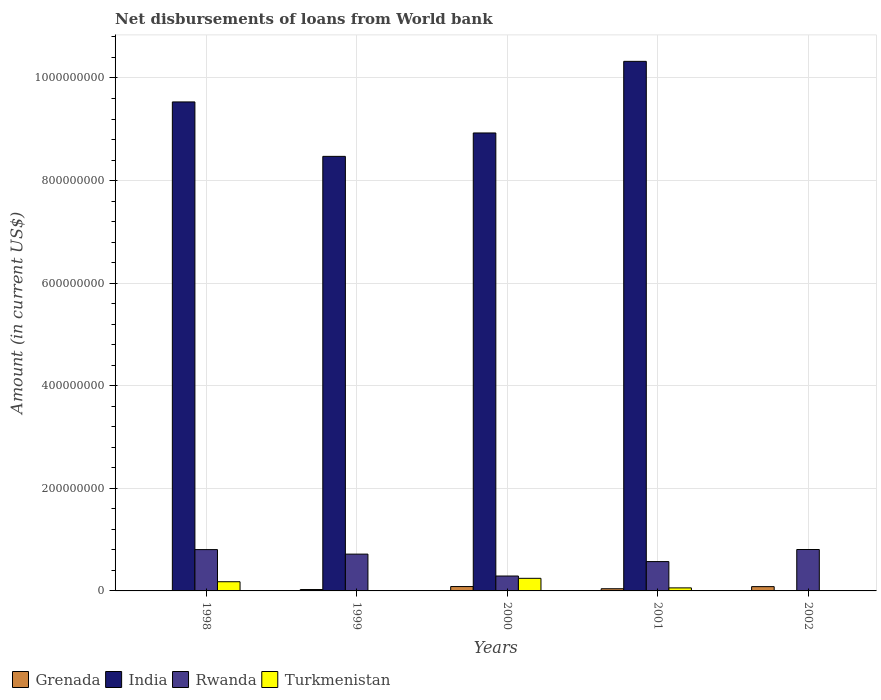How many different coloured bars are there?
Keep it short and to the point. 4. How many groups of bars are there?
Give a very brief answer. 5. Are the number of bars per tick equal to the number of legend labels?
Provide a short and direct response. No. Are the number of bars on each tick of the X-axis equal?
Ensure brevity in your answer.  No. How many bars are there on the 2nd tick from the left?
Your response must be concise. 4. How many bars are there on the 3rd tick from the right?
Your answer should be very brief. 4. In how many cases, is the number of bars for a given year not equal to the number of legend labels?
Offer a terse response. 2. What is the amount of loan disbursed from World Bank in Turkmenistan in 2002?
Provide a short and direct response. 0. Across all years, what is the maximum amount of loan disbursed from World Bank in Turkmenistan?
Make the answer very short. 2.46e+07. Across all years, what is the minimum amount of loan disbursed from World Bank in Rwanda?
Your answer should be very brief. 2.90e+07. In which year was the amount of loan disbursed from World Bank in Turkmenistan maximum?
Offer a terse response. 2000. What is the total amount of loan disbursed from World Bank in Grenada in the graph?
Make the answer very short. 2.38e+07. What is the difference between the amount of loan disbursed from World Bank in Turkmenistan in 1998 and that in 1999?
Offer a terse response. 1.73e+07. What is the difference between the amount of loan disbursed from World Bank in Grenada in 2000 and the amount of loan disbursed from World Bank in India in 2002?
Offer a terse response. 8.52e+06. What is the average amount of loan disbursed from World Bank in Grenada per year?
Offer a terse response. 4.77e+06. In the year 2001, what is the difference between the amount of loan disbursed from World Bank in Grenada and amount of loan disbursed from World Bank in India?
Provide a succinct answer. -1.03e+09. In how many years, is the amount of loan disbursed from World Bank in India greater than 920000000 US$?
Offer a very short reply. 2. What is the ratio of the amount of loan disbursed from World Bank in Rwanda in 2000 to that in 2002?
Give a very brief answer. 0.36. Is the difference between the amount of loan disbursed from World Bank in Grenada in 1999 and 2001 greater than the difference between the amount of loan disbursed from World Bank in India in 1999 and 2001?
Your answer should be very brief. Yes. What is the difference between the highest and the second highest amount of loan disbursed from World Bank in Rwanda?
Your answer should be compact. 1.67e+05. What is the difference between the highest and the lowest amount of loan disbursed from World Bank in Rwanda?
Your answer should be very brief. 5.17e+07. In how many years, is the amount of loan disbursed from World Bank in Rwanda greater than the average amount of loan disbursed from World Bank in Rwanda taken over all years?
Your response must be concise. 3. How many bars are there?
Keep it short and to the point. 17. Are the values on the major ticks of Y-axis written in scientific E-notation?
Your response must be concise. No. Does the graph contain any zero values?
Offer a terse response. Yes. Does the graph contain grids?
Give a very brief answer. Yes. How are the legend labels stacked?
Provide a succinct answer. Horizontal. What is the title of the graph?
Your answer should be compact. Net disbursements of loans from World bank. Does "Cameroon" appear as one of the legend labels in the graph?
Offer a terse response. No. What is the label or title of the Y-axis?
Keep it short and to the point. Amount (in current US$). What is the Amount (in current US$) in India in 1998?
Offer a terse response. 9.53e+08. What is the Amount (in current US$) of Rwanda in 1998?
Your response must be concise. 8.06e+07. What is the Amount (in current US$) of Turkmenistan in 1998?
Make the answer very short. 1.79e+07. What is the Amount (in current US$) in Grenada in 1999?
Provide a succinct answer. 2.70e+06. What is the Amount (in current US$) in India in 1999?
Make the answer very short. 8.47e+08. What is the Amount (in current US$) in Rwanda in 1999?
Offer a very short reply. 7.18e+07. What is the Amount (in current US$) in Turkmenistan in 1999?
Your response must be concise. 5.75e+05. What is the Amount (in current US$) in Grenada in 2000?
Offer a terse response. 8.52e+06. What is the Amount (in current US$) of India in 2000?
Make the answer very short. 8.93e+08. What is the Amount (in current US$) of Rwanda in 2000?
Ensure brevity in your answer.  2.90e+07. What is the Amount (in current US$) of Turkmenistan in 2000?
Give a very brief answer. 2.46e+07. What is the Amount (in current US$) in Grenada in 2001?
Offer a terse response. 4.25e+06. What is the Amount (in current US$) of India in 2001?
Provide a succinct answer. 1.03e+09. What is the Amount (in current US$) of Rwanda in 2001?
Provide a short and direct response. 5.72e+07. What is the Amount (in current US$) of Turkmenistan in 2001?
Offer a very short reply. 5.93e+06. What is the Amount (in current US$) of Grenada in 2002?
Make the answer very short. 8.38e+06. What is the Amount (in current US$) of India in 2002?
Offer a terse response. 0. What is the Amount (in current US$) of Rwanda in 2002?
Offer a terse response. 8.07e+07. What is the Amount (in current US$) in Turkmenistan in 2002?
Provide a short and direct response. 0. Across all years, what is the maximum Amount (in current US$) in Grenada?
Provide a succinct answer. 8.52e+06. Across all years, what is the maximum Amount (in current US$) of India?
Your answer should be compact. 1.03e+09. Across all years, what is the maximum Amount (in current US$) of Rwanda?
Provide a succinct answer. 8.07e+07. Across all years, what is the maximum Amount (in current US$) in Turkmenistan?
Offer a very short reply. 2.46e+07. Across all years, what is the minimum Amount (in current US$) in Grenada?
Give a very brief answer. 0. Across all years, what is the minimum Amount (in current US$) of Rwanda?
Your answer should be very brief. 2.90e+07. Across all years, what is the minimum Amount (in current US$) of Turkmenistan?
Give a very brief answer. 0. What is the total Amount (in current US$) in Grenada in the graph?
Provide a short and direct response. 2.38e+07. What is the total Amount (in current US$) in India in the graph?
Ensure brevity in your answer.  3.73e+09. What is the total Amount (in current US$) of Rwanda in the graph?
Your response must be concise. 3.19e+08. What is the total Amount (in current US$) in Turkmenistan in the graph?
Make the answer very short. 4.90e+07. What is the difference between the Amount (in current US$) of India in 1998 and that in 1999?
Make the answer very short. 1.06e+08. What is the difference between the Amount (in current US$) in Rwanda in 1998 and that in 1999?
Ensure brevity in your answer.  8.81e+06. What is the difference between the Amount (in current US$) of Turkmenistan in 1998 and that in 1999?
Your response must be concise. 1.73e+07. What is the difference between the Amount (in current US$) in India in 1998 and that in 2000?
Your answer should be very brief. 6.05e+07. What is the difference between the Amount (in current US$) in Rwanda in 1998 and that in 2000?
Ensure brevity in your answer.  5.15e+07. What is the difference between the Amount (in current US$) of Turkmenistan in 1998 and that in 2000?
Make the answer very short. -6.65e+06. What is the difference between the Amount (in current US$) of India in 1998 and that in 2001?
Provide a short and direct response. -7.91e+07. What is the difference between the Amount (in current US$) in Rwanda in 1998 and that in 2001?
Offer a very short reply. 2.34e+07. What is the difference between the Amount (in current US$) in Turkmenistan in 1998 and that in 2001?
Make the answer very short. 1.20e+07. What is the difference between the Amount (in current US$) in Rwanda in 1998 and that in 2002?
Provide a succinct answer. -1.67e+05. What is the difference between the Amount (in current US$) in Grenada in 1999 and that in 2000?
Provide a short and direct response. -5.82e+06. What is the difference between the Amount (in current US$) in India in 1999 and that in 2000?
Your response must be concise. -4.56e+07. What is the difference between the Amount (in current US$) in Rwanda in 1999 and that in 2000?
Your response must be concise. 4.27e+07. What is the difference between the Amount (in current US$) of Turkmenistan in 1999 and that in 2000?
Provide a short and direct response. -2.40e+07. What is the difference between the Amount (in current US$) of Grenada in 1999 and that in 2001?
Ensure brevity in your answer.  -1.55e+06. What is the difference between the Amount (in current US$) in India in 1999 and that in 2001?
Give a very brief answer. -1.85e+08. What is the difference between the Amount (in current US$) of Rwanda in 1999 and that in 2001?
Provide a succinct answer. 1.46e+07. What is the difference between the Amount (in current US$) of Turkmenistan in 1999 and that in 2001?
Give a very brief answer. -5.36e+06. What is the difference between the Amount (in current US$) in Grenada in 1999 and that in 2002?
Your answer should be very brief. -5.67e+06. What is the difference between the Amount (in current US$) in Rwanda in 1999 and that in 2002?
Keep it short and to the point. -8.98e+06. What is the difference between the Amount (in current US$) of Grenada in 2000 and that in 2001?
Your answer should be very brief. 4.27e+06. What is the difference between the Amount (in current US$) of India in 2000 and that in 2001?
Your answer should be compact. -1.40e+08. What is the difference between the Amount (in current US$) in Rwanda in 2000 and that in 2001?
Offer a terse response. -2.82e+07. What is the difference between the Amount (in current US$) in Turkmenistan in 2000 and that in 2001?
Give a very brief answer. 1.86e+07. What is the difference between the Amount (in current US$) in Grenada in 2000 and that in 2002?
Give a very brief answer. 1.44e+05. What is the difference between the Amount (in current US$) in Rwanda in 2000 and that in 2002?
Provide a short and direct response. -5.17e+07. What is the difference between the Amount (in current US$) of Grenada in 2001 and that in 2002?
Your response must be concise. -4.12e+06. What is the difference between the Amount (in current US$) in Rwanda in 2001 and that in 2002?
Keep it short and to the point. -2.35e+07. What is the difference between the Amount (in current US$) of India in 1998 and the Amount (in current US$) of Rwanda in 1999?
Provide a succinct answer. 8.82e+08. What is the difference between the Amount (in current US$) in India in 1998 and the Amount (in current US$) in Turkmenistan in 1999?
Keep it short and to the point. 9.53e+08. What is the difference between the Amount (in current US$) of Rwanda in 1998 and the Amount (in current US$) of Turkmenistan in 1999?
Your answer should be compact. 8.00e+07. What is the difference between the Amount (in current US$) of India in 1998 and the Amount (in current US$) of Rwanda in 2000?
Your response must be concise. 9.24e+08. What is the difference between the Amount (in current US$) of India in 1998 and the Amount (in current US$) of Turkmenistan in 2000?
Your answer should be very brief. 9.29e+08. What is the difference between the Amount (in current US$) in Rwanda in 1998 and the Amount (in current US$) in Turkmenistan in 2000?
Make the answer very short. 5.60e+07. What is the difference between the Amount (in current US$) of India in 1998 and the Amount (in current US$) of Rwanda in 2001?
Make the answer very short. 8.96e+08. What is the difference between the Amount (in current US$) in India in 1998 and the Amount (in current US$) in Turkmenistan in 2001?
Make the answer very short. 9.47e+08. What is the difference between the Amount (in current US$) in Rwanda in 1998 and the Amount (in current US$) in Turkmenistan in 2001?
Give a very brief answer. 7.46e+07. What is the difference between the Amount (in current US$) of India in 1998 and the Amount (in current US$) of Rwanda in 2002?
Keep it short and to the point. 8.73e+08. What is the difference between the Amount (in current US$) in Grenada in 1999 and the Amount (in current US$) in India in 2000?
Provide a short and direct response. -8.90e+08. What is the difference between the Amount (in current US$) in Grenada in 1999 and the Amount (in current US$) in Rwanda in 2000?
Offer a very short reply. -2.63e+07. What is the difference between the Amount (in current US$) of Grenada in 1999 and the Amount (in current US$) of Turkmenistan in 2000?
Keep it short and to the point. -2.19e+07. What is the difference between the Amount (in current US$) in India in 1999 and the Amount (in current US$) in Rwanda in 2000?
Your response must be concise. 8.18e+08. What is the difference between the Amount (in current US$) of India in 1999 and the Amount (in current US$) of Turkmenistan in 2000?
Provide a succinct answer. 8.23e+08. What is the difference between the Amount (in current US$) in Rwanda in 1999 and the Amount (in current US$) in Turkmenistan in 2000?
Keep it short and to the point. 4.72e+07. What is the difference between the Amount (in current US$) of Grenada in 1999 and the Amount (in current US$) of India in 2001?
Provide a succinct answer. -1.03e+09. What is the difference between the Amount (in current US$) of Grenada in 1999 and the Amount (in current US$) of Rwanda in 2001?
Offer a very short reply. -5.45e+07. What is the difference between the Amount (in current US$) in Grenada in 1999 and the Amount (in current US$) in Turkmenistan in 2001?
Your answer should be very brief. -3.23e+06. What is the difference between the Amount (in current US$) in India in 1999 and the Amount (in current US$) in Rwanda in 2001?
Offer a very short reply. 7.90e+08. What is the difference between the Amount (in current US$) of India in 1999 and the Amount (in current US$) of Turkmenistan in 2001?
Ensure brevity in your answer.  8.41e+08. What is the difference between the Amount (in current US$) of Rwanda in 1999 and the Amount (in current US$) of Turkmenistan in 2001?
Provide a succinct answer. 6.58e+07. What is the difference between the Amount (in current US$) of Grenada in 1999 and the Amount (in current US$) of Rwanda in 2002?
Your answer should be compact. -7.80e+07. What is the difference between the Amount (in current US$) of India in 1999 and the Amount (in current US$) of Rwanda in 2002?
Ensure brevity in your answer.  7.66e+08. What is the difference between the Amount (in current US$) in Grenada in 2000 and the Amount (in current US$) in India in 2001?
Your answer should be compact. -1.02e+09. What is the difference between the Amount (in current US$) in Grenada in 2000 and the Amount (in current US$) in Rwanda in 2001?
Ensure brevity in your answer.  -4.87e+07. What is the difference between the Amount (in current US$) of Grenada in 2000 and the Amount (in current US$) of Turkmenistan in 2001?
Give a very brief answer. 2.59e+06. What is the difference between the Amount (in current US$) of India in 2000 and the Amount (in current US$) of Rwanda in 2001?
Your answer should be compact. 8.36e+08. What is the difference between the Amount (in current US$) of India in 2000 and the Amount (in current US$) of Turkmenistan in 2001?
Your answer should be compact. 8.87e+08. What is the difference between the Amount (in current US$) of Rwanda in 2000 and the Amount (in current US$) of Turkmenistan in 2001?
Offer a terse response. 2.31e+07. What is the difference between the Amount (in current US$) of Grenada in 2000 and the Amount (in current US$) of Rwanda in 2002?
Keep it short and to the point. -7.22e+07. What is the difference between the Amount (in current US$) in India in 2000 and the Amount (in current US$) in Rwanda in 2002?
Your response must be concise. 8.12e+08. What is the difference between the Amount (in current US$) in Grenada in 2001 and the Amount (in current US$) in Rwanda in 2002?
Provide a short and direct response. -7.65e+07. What is the difference between the Amount (in current US$) of India in 2001 and the Amount (in current US$) of Rwanda in 2002?
Your answer should be compact. 9.52e+08. What is the average Amount (in current US$) in Grenada per year?
Keep it short and to the point. 4.77e+06. What is the average Amount (in current US$) of India per year?
Provide a short and direct response. 7.45e+08. What is the average Amount (in current US$) of Rwanda per year?
Your response must be concise. 6.39e+07. What is the average Amount (in current US$) in Turkmenistan per year?
Provide a succinct answer. 9.80e+06. In the year 1998, what is the difference between the Amount (in current US$) of India and Amount (in current US$) of Rwanda?
Your answer should be compact. 8.73e+08. In the year 1998, what is the difference between the Amount (in current US$) in India and Amount (in current US$) in Turkmenistan?
Offer a terse response. 9.35e+08. In the year 1998, what is the difference between the Amount (in current US$) of Rwanda and Amount (in current US$) of Turkmenistan?
Provide a succinct answer. 6.26e+07. In the year 1999, what is the difference between the Amount (in current US$) of Grenada and Amount (in current US$) of India?
Give a very brief answer. -8.44e+08. In the year 1999, what is the difference between the Amount (in current US$) in Grenada and Amount (in current US$) in Rwanda?
Your response must be concise. -6.91e+07. In the year 1999, what is the difference between the Amount (in current US$) of Grenada and Amount (in current US$) of Turkmenistan?
Your answer should be very brief. 2.13e+06. In the year 1999, what is the difference between the Amount (in current US$) of India and Amount (in current US$) of Rwanda?
Ensure brevity in your answer.  7.75e+08. In the year 1999, what is the difference between the Amount (in current US$) of India and Amount (in current US$) of Turkmenistan?
Give a very brief answer. 8.47e+08. In the year 1999, what is the difference between the Amount (in current US$) in Rwanda and Amount (in current US$) in Turkmenistan?
Your answer should be compact. 7.12e+07. In the year 2000, what is the difference between the Amount (in current US$) of Grenada and Amount (in current US$) of India?
Offer a very short reply. -8.84e+08. In the year 2000, what is the difference between the Amount (in current US$) in Grenada and Amount (in current US$) in Rwanda?
Your answer should be compact. -2.05e+07. In the year 2000, what is the difference between the Amount (in current US$) of Grenada and Amount (in current US$) of Turkmenistan?
Your answer should be very brief. -1.60e+07. In the year 2000, what is the difference between the Amount (in current US$) in India and Amount (in current US$) in Rwanda?
Keep it short and to the point. 8.64e+08. In the year 2000, what is the difference between the Amount (in current US$) in India and Amount (in current US$) in Turkmenistan?
Provide a short and direct response. 8.68e+08. In the year 2000, what is the difference between the Amount (in current US$) of Rwanda and Amount (in current US$) of Turkmenistan?
Offer a terse response. 4.47e+06. In the year 2001, what is the difference between the Amount (in current US$) of Grenada and Amount (in current US$) of India?
Provide a short and direct response. -1.03e+09. In the year 2001, what is the difference between the Amount (in current US$) in Grenada and Amount (in current US$) in Rwanda?
Ensure brevity in your answer.  -5.29e+07. In the year 2001, what is the difference between the Amount (in current US$) in Grenada and Amount (in current US$) in Turkmenistan?
Your answer should be compact. -1.68e+06. In the year 2001, what is the difference between the Amount (in current US$) in India and Amount (in current US$) in Rwanda?
Provide a succinct answer. 9.75e+08. In the year 2001, what is the difference between the Amount (in current US$) in India and Amount (in current US$) in Turkmenistan?
Your response must be concise. 1.03e+09. In the year 2001, what is the difference between the Amount (in current US$) in Rwanda and Amount (in current US$) in Turkmenistan?
Provide a succinct answer. 5.13e+07. In the year 2002, what is the difference between the Amount (in current US$) of Grenada and Amount (in current US$) of Rwanda?
Your answer should be compact. -7.24e+07. What is the ratio of the Amount (in current US$) in India in 1998 to that in 1999?
Offer a very short reply. 1.13. What is the ratio of the Amount (in current US$) in Rwanda in 1998 to that in 1999?
Your response must be concise. 1.12. What is the ratio of the Amount (in current US$) in Turkmenistan in 1998 to that in 1999?
Your response must be concise. 31.16. What is the ratio of the Amount (in current US$) in India in 1998 to that in 2000?
Offer a very short reply. 1.07. What is the ratio of the Amount (in current US$) in Rwanda in 1998 to that in 2000?
Keep it short and to the point. 2.77. What is the ratio of the Amount (in current US$) of Turkmenistan in 1998 to that in 2000?
Offer a terse response. 0.73. What is the ratio of the Amount (in current US$) in India in 1998 to that in 2001?
Your answer should be very brief. 0.92. What is the ratio of the Amount (in current US$) in Rwanda in 1998 to that in 2001?
Keep it short and to the point. 1.41. What is the ratio of the Amount (in current US$) of Turkmenistan in 1998 to that in 2001?
Provide a short and direct response. 3.02. What is the ratio of the Amount (in current US$) of Rwanda in 1998 to that in 2002?
Your response must be concise. 1. What is the ratio of the Amount (in current US$) of Grenada in 1999 to that in 2000?
Provide a succinct answer. 0.32. What is the ratio of the Amount (in current US$) of India in 1999 to that in 2000?
Offer a terse response. 0.95. What is the ratio of the Amount (in current US$) in Rwanda in 1999 to that in 2000?
Your answer should be compact. 2.47. What is the ratio of the Amount (in current US$) in Turkmenistan in 1999 to that in 2000?
Provide a short and direct response. 0.02. What is the ratio of the Amount (in current US$) in Grenada in 1999 to that in 2001?
Provide a short and direct response. 0.64. What is the ratio of the Amount (in current US$) in India in 1999 to that in 2001?
Provide a succinct answer. 0.82. What is the ratio of the Amount (in current US$) of Rwanda in 1999 to that in 2001?
Ensure brevity in your answer.  1.25. What is the ratio of the Amount (in current US$) of Turkmenistan in 1999 to that in 2001?
Keep it short and to the point. 0.1. What is the ratio of the Amount (in current US$) in Grenada in 1999 to that in 2002?
Ensure brevity in your answer.  0.32. What is the ratio of the Amount (in current US$) of Rwanda in 1999 to that in 2002?
Provide a short and direct response. 0.89. What is the ratio of the Amount (in current US$) of Grenada in 2000 to that in 2001?
Your answer should be very brief. 2. What is the ratio of the Amount (in current US$) of India in 2000 to that in 2001?
Your answer should be compact. 0.86. What is the ratio of the Amount (in current US$) in Rwanda in 2000 to that in 2001?
Your response must be concise. 0.51. What is the ratio of the Amount (in current US$) in Turkmenistan in 2000 to that in 2001?
Your answer should be compact. 4.14. What is the ratio of the Amount (in current US$) in Grenada in 2000 to that in 2002?
Ensure brevity in your answer.  1.02. What is the ratio of the Amount (in current US$) of Rwanda in 2000 to that in 2002?
Provide a short and direct response. 0.36. What is the ratio of the Amount (in current US$) in Grenada in 2001 to that in 2002?
Keep it short and to the point. 0.51. What is the ratio of the Amount (in current US$) of Rwanda in 2001 to that in 2002?
Keep it short and to the point. 0.71. What is the difference between the highest and the second highest Amount (in current US$) of Grenada?
Provide a short and direct response. 1.44e+05. What is the difference between the highest and the second highest Amount (in current US$) of India?
Your response must be concise. 7.91e+07. What is the difference between the highest and the second highest Amount (in current US$) of Rwanda?
Offer a terse response. 1.67e+05. What is the difference between the highest and the second highest Amount (in current US$) of Turkmenistan?
Give a very brief answer. 6.65e+06. What is the difference between the highest and the lowest Amount (in current US$) in Grenada?
Provide a short and direct response. 8.52e+06. What is the difference between the highest and the lowest Amount (in current US$) in India?
Make the answer very short. 1.03e+09. What is the difference between the highest and the lowest Amount (in current US$) of Rwanda?
Offer a terse response. 5.17e+07. What is the difference between the highest and the lowest Amount (in current US$) in Turkmenistan?
Offer a very short reply. 2.46e+07. 